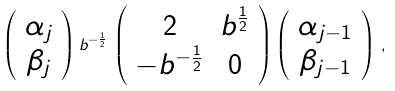Convert formula to latex. <formula><loc_0><loc_0><loc_500><loc_500>\left ( \begin{array} { c } \alpha _ { j } \\ \beta _ { j } \end{array} \right ) b ^ { - \frac { 1 } { 2 } } \, \left ( \begin{array} { c c } 2 & b ^ { \frac { 1 } { 2 } } \\ - b ^ { - \frac { 1 } { 2 } } & 0 \end{array} \right ) \left ( \begin{array} { c } \alpha _ { j - 1 } \\ \beta _ { j - 1 } \end{array} \right ) \, ,</formula> 